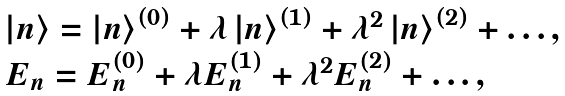Convert formula to latex. <formula><loc_0><loc_0><loc_500><loc_500>\begin{array} { l } \left | n \right \rangle = \left | n \right \rangle ^ { \left ( 0 \right ) } + \lambda \left | n \right \rangle ^ { \left ( 1 \right ) } + \lambda ^ { 2 } \left | n \right \rangle ^ { \left ( 2 \right ) } + \dots , \\ E _ { n } = E _ { n } ^ { ( 0 ) } + \lambda E _ { n } ^ { ( 1 ) } + \lambda ^ { 2 } E _ { n } ^ { ( 2 ) } + \dots , \\ \end{array}</formula> 